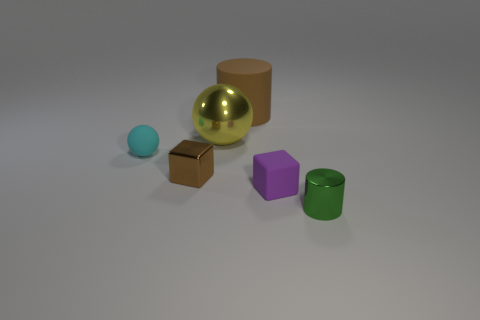There is a cylinder that is on the left side of the purple cube; is it the same color as the small shiny cube? yes 